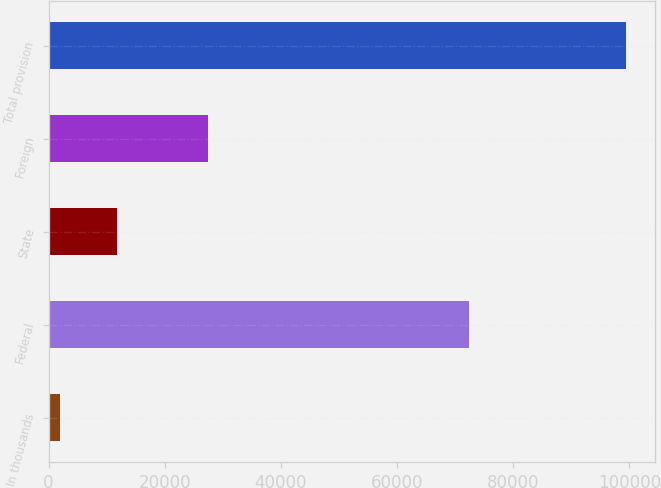<chart> <loc_0><loc_0><loc_500><loc_500><bar_chart><fcel>In thousands<fcel>Federal<fcel>State<fcel>Foreign<fcel>Total provision<nl><fcel>2016<fcel>72317<fcel>11757.7<fcel>27391<fcel>99433<nl></chart> 